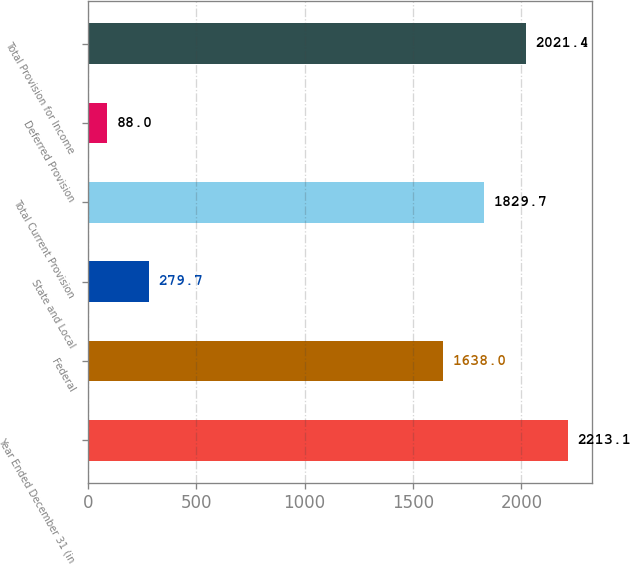<chart> <loc_0><loc_0><loc_500><loc_500><bar_chart><fcel>Year Ended December 31 (in<fcel>Federal<fcel>State and Local<fcel>Total Current Provision<fcel>Deferred Provision<fcel>Total Provision for Income<nl><fcel>2213.1<fcel>1638<fcel>279.7<fcel>1829.7<fcel>88<fcel>2021.4<nl></chart> 